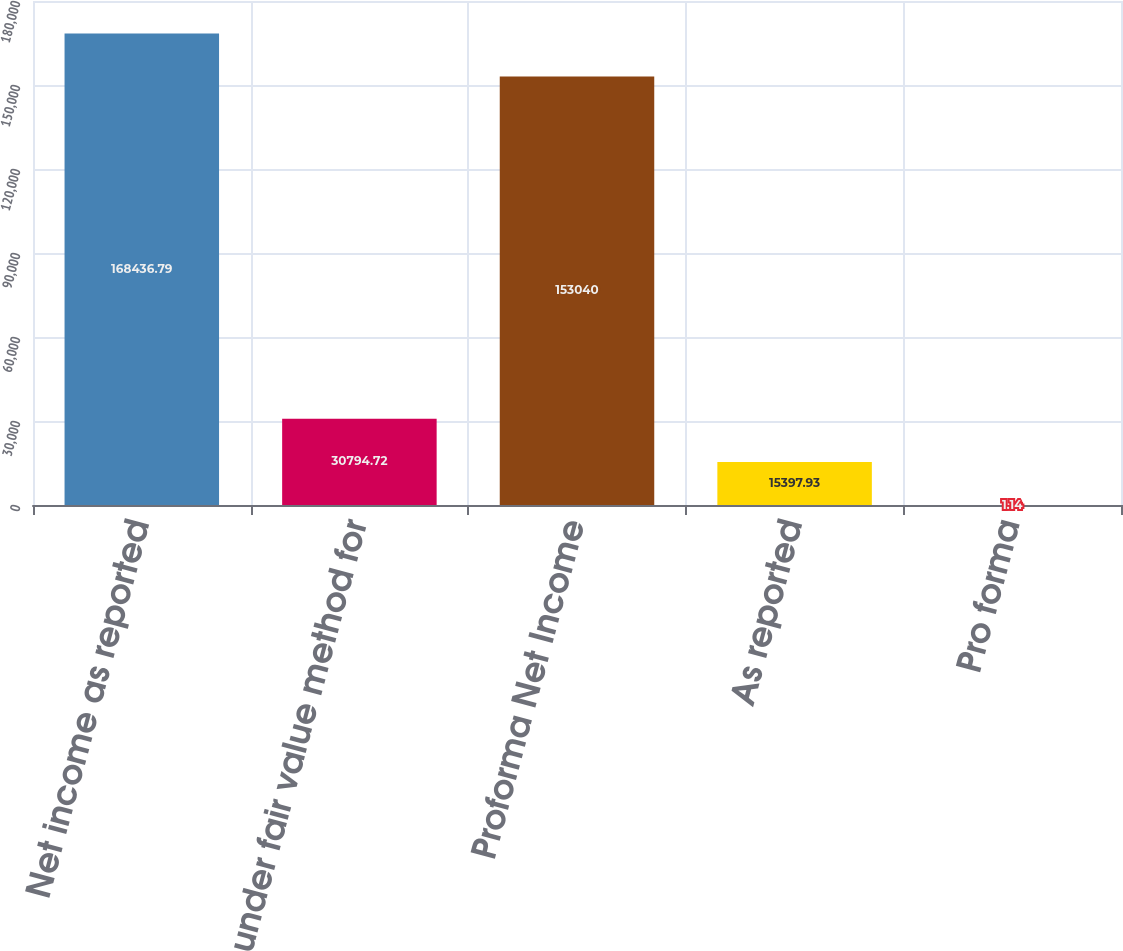<chart> <loc_0><loc_0><loc_500><loc_500><bar_chart><fcel>Net income as reported<fcel>under fair value method for<fcel>Proforma Net Income<fcel>As reported<fcel>Pro forma<nl><fcel>168437<fcel>30794.7<fcel>153040<fcel>15397.9<fcel>1.14<nl></chart> 